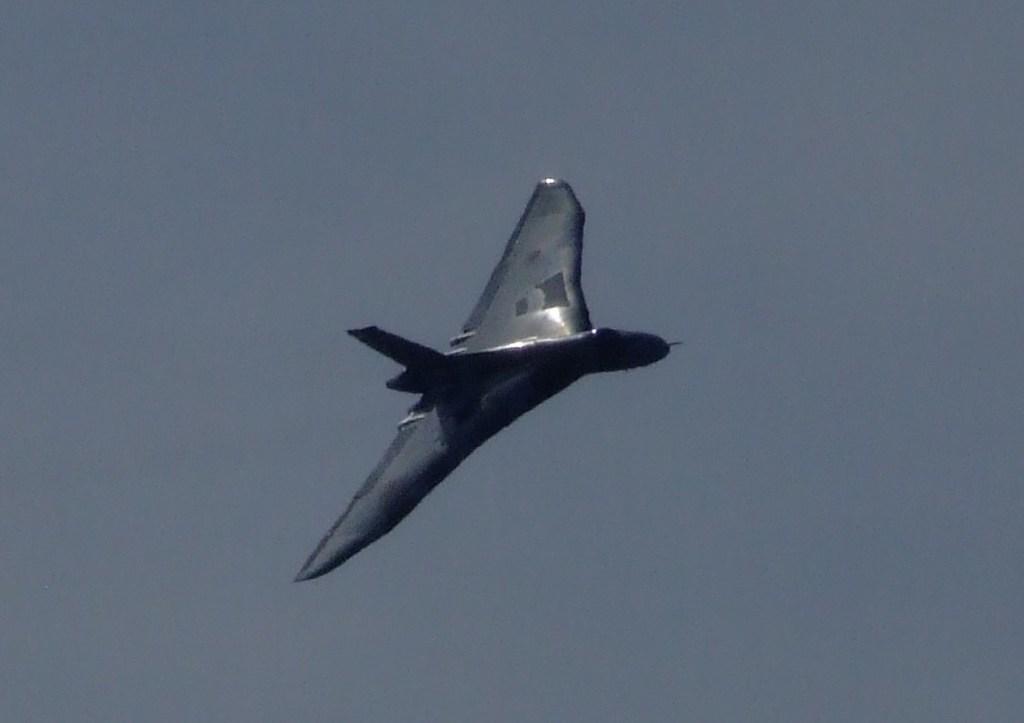Could you give a brief overview of what you see in this image? In the middle I can see an aircraft. The background is grey in color. This image is taken may be in the evening. 